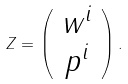<formula> <loc_0><loc_0><loc_500><loc_500>Z = \left ( \begin{array} { c } w ^ { i } \\ p ^ { i } \\ \end{array} \right ) .</formula> 